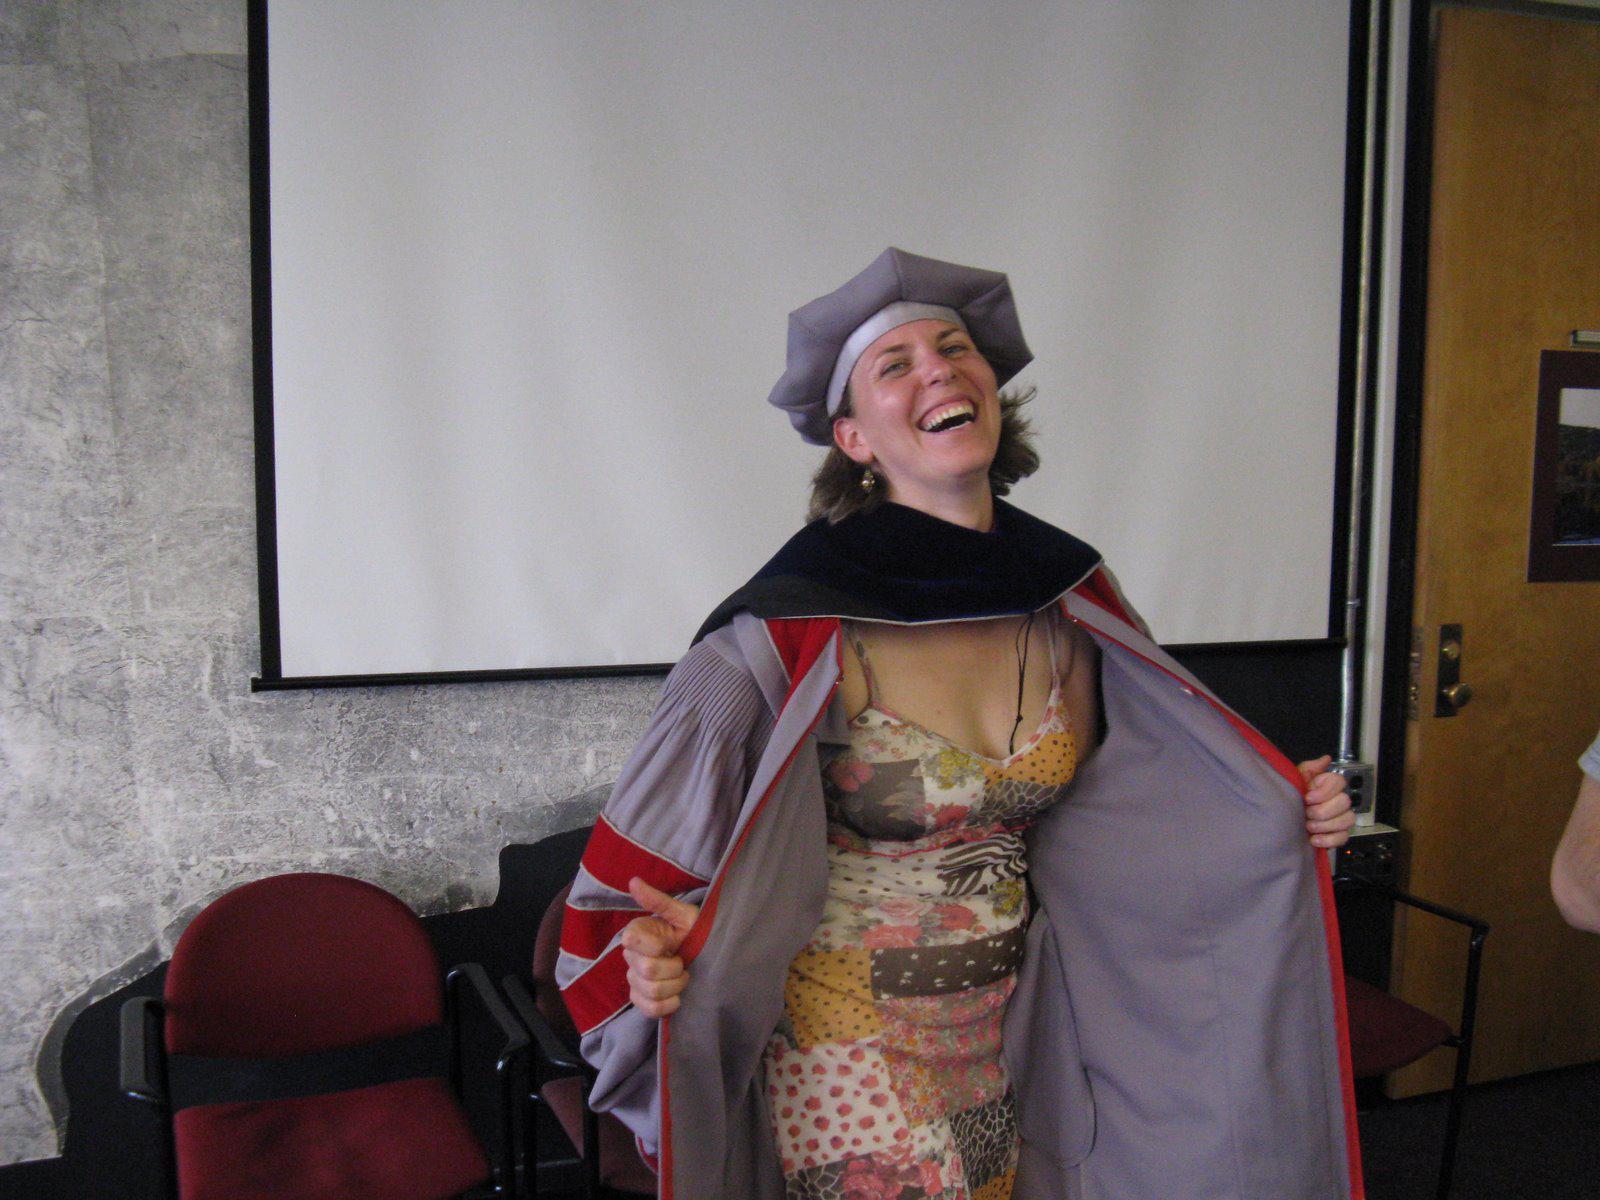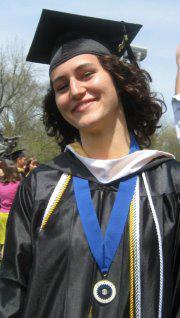The first image is the image on the left, the second image is the image on the right. Evaluate the accuracy of this statement regarding the images: "One image includes at least one male in a royal blue graduation gown and cap, and the other image contains no male graduates.". Is it true? Answer yes or no. No. 